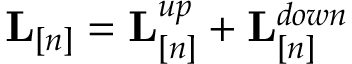<formula> <loc_0><loc_0><loc_500><loc_500>{ L } _ { [ n ] } = { L } _ { [ n ] } ^ { u p } + { L } _ { [ n ] } ^ { d o w n }</formula> 